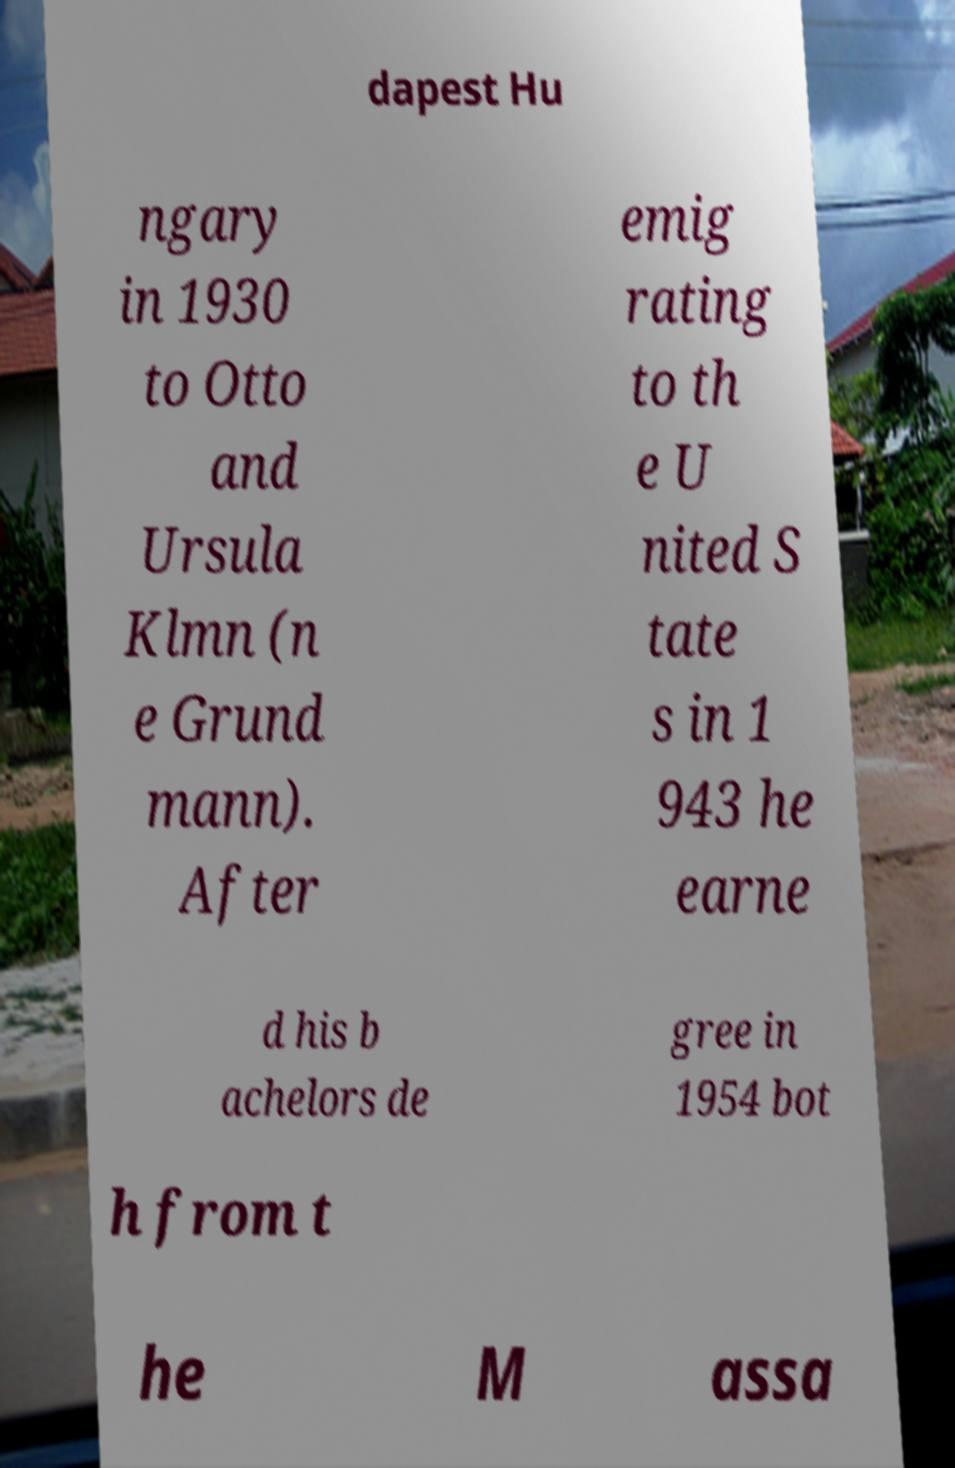For documentation purposes, I need the text within this image transcribed. Could you provide that? dapest Hu ngary in 1930 to Otto and Ursula Klmn (n e Grund mann). After emig rating to th e U nited S tate s in 1 943 he earne d his b achelors de gree in 1954 bot h from t he M assa 